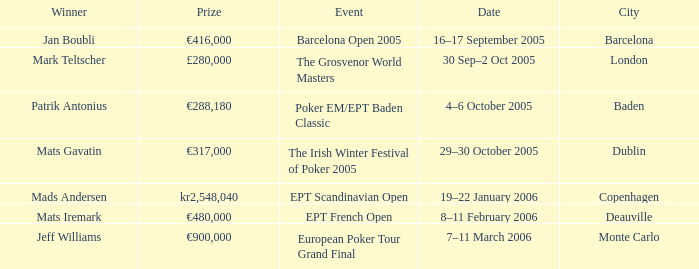When was the event in the City of Baden? 4–6 October 2005. 